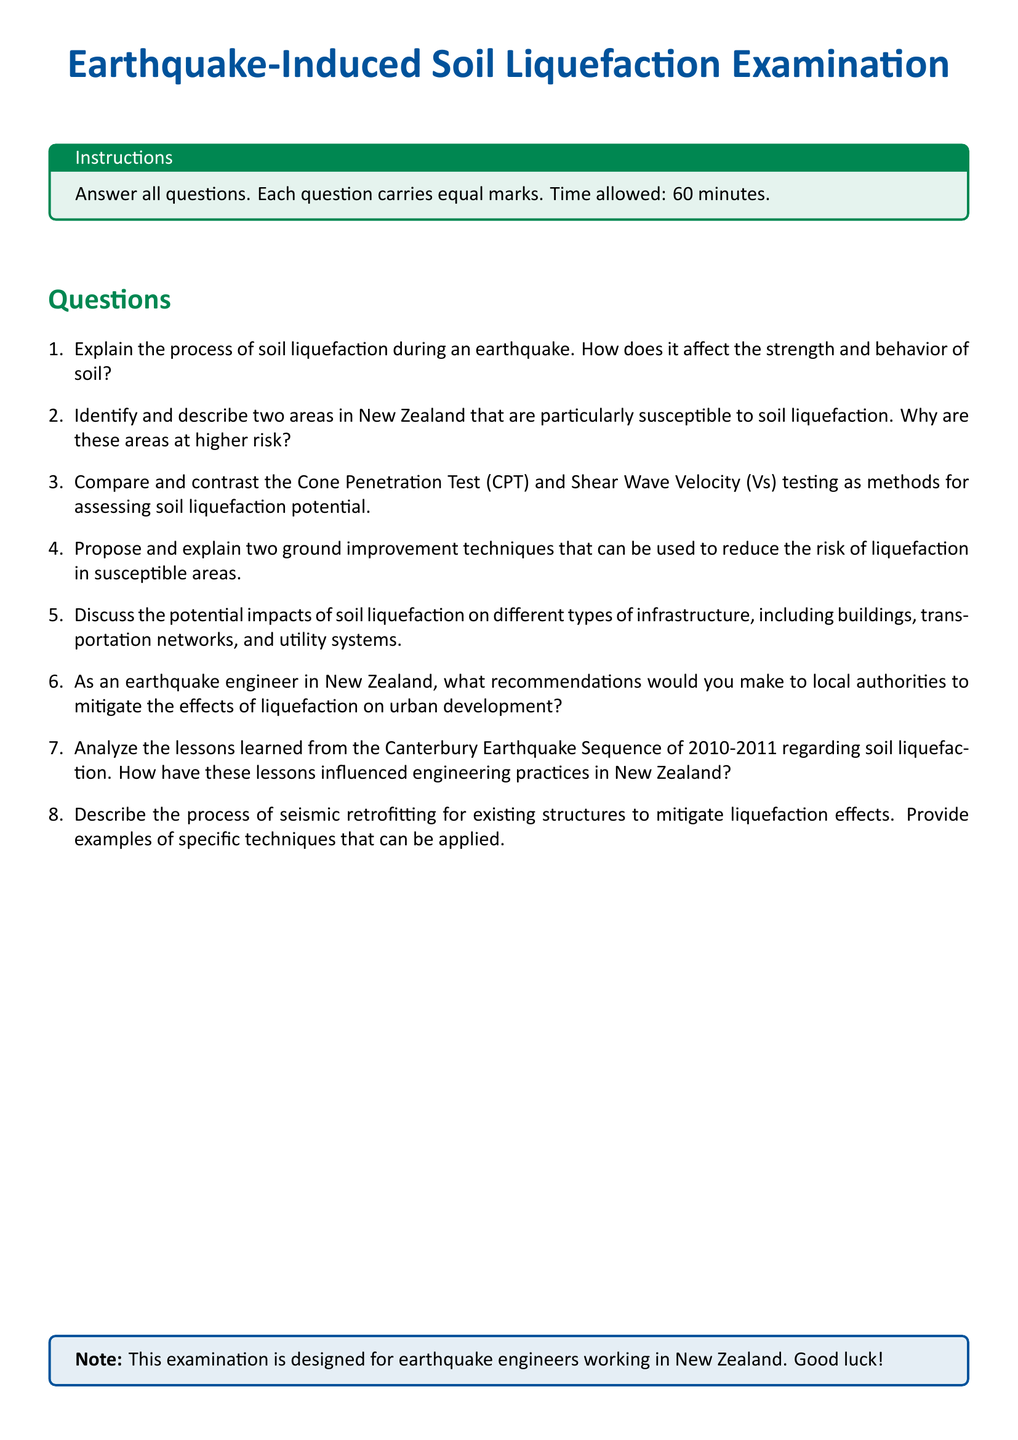what is the title of the document? The title is presented prominently at the beginning of the document, indicating the focus of the examination.
Answer: Earthquake-Induced Soil Liquefaction Examination how many questions are in the examination? The examination clearly lists the number of questions in a structured enumeration format, indicating a total of eight questions.
Answer: 8 what color is used for the section headings? The section headings are formatted in a specific color to enhance visibility and organization within the document.
Answer: nzgreen what is the time allowed for the examination? The instructions section specifies the duration students have to complete the examination, which is stated directly.
Answer: 60 minutes name one technique proposed to reduce the risk of liquefaction. This question is directed towards identifying mitigation strategies discussed in the examination questions.
Answer: ground improvement techniques which earthquake event is referred to in the examination? The examination discusses a specific historical seismic event that has implications for learning and engineering practices in New Zealand.
Answer: Canterbury Earthquake Sequence of 2010-2011 how many marks does each question carry? The instructions part of the document clearly indicates the scoring system for the examination questions.
Answer: equal marks what is the purpose of the document? The document serves a specific educational purpose as indicated by the title and context provided within the examination structure.
Answer: examination for earthquake engineers 